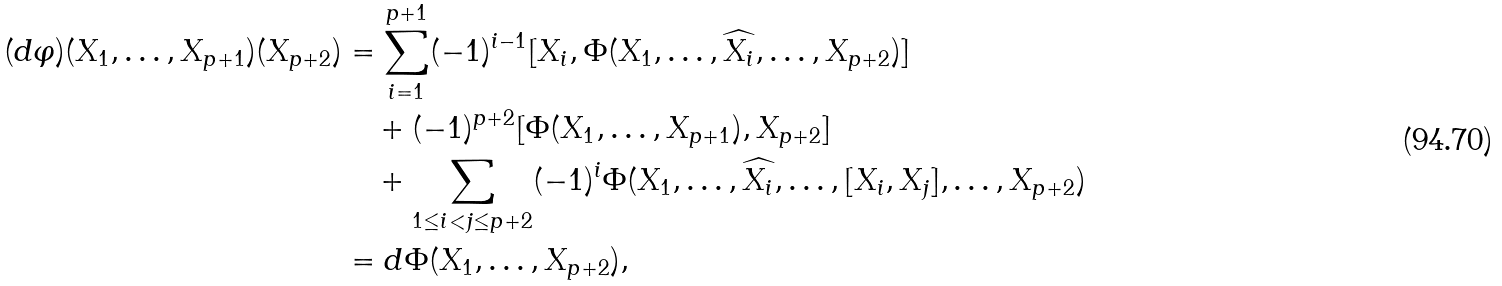Convert formula to latex. <formula><loc_0><loc_0><loc_500><loc_500>( d \varphi ) ( X _ { 1 } , \dots , X _ { p + 1 } ) ( X _ { p + 2 } ) & = \sum _ { i = 1 } ^ { p + 1 } ( - 1 ) ^ { i - 1 } [ X _ { i } , \Phi ( X _ { 1 } , \dots , \widehat { X _ { i } } , \dots , X _ { p + 2 } ) ] \\ & \quad + ( - 1 ) ^ { p + 2 } [ \Phi ( X _ { 1 } , \dots , X _ { p + 1 } ) , X _ { p + 2 } ] \\ & \quad + \sum _ { 1 \leq i < j \leq p + 2 } ( - 1 ) ^ { i } \Phi ( X _ { 1 } , \dots , \widehat { X _ { i } } , \dots , [ X _ { i } , X _ { j } ] , \dots , X _ { p + 2 } ) \\ & = d \Phi ( X _ { 1 } , \dots , X _ { p + 2 } ) ,</formula> 